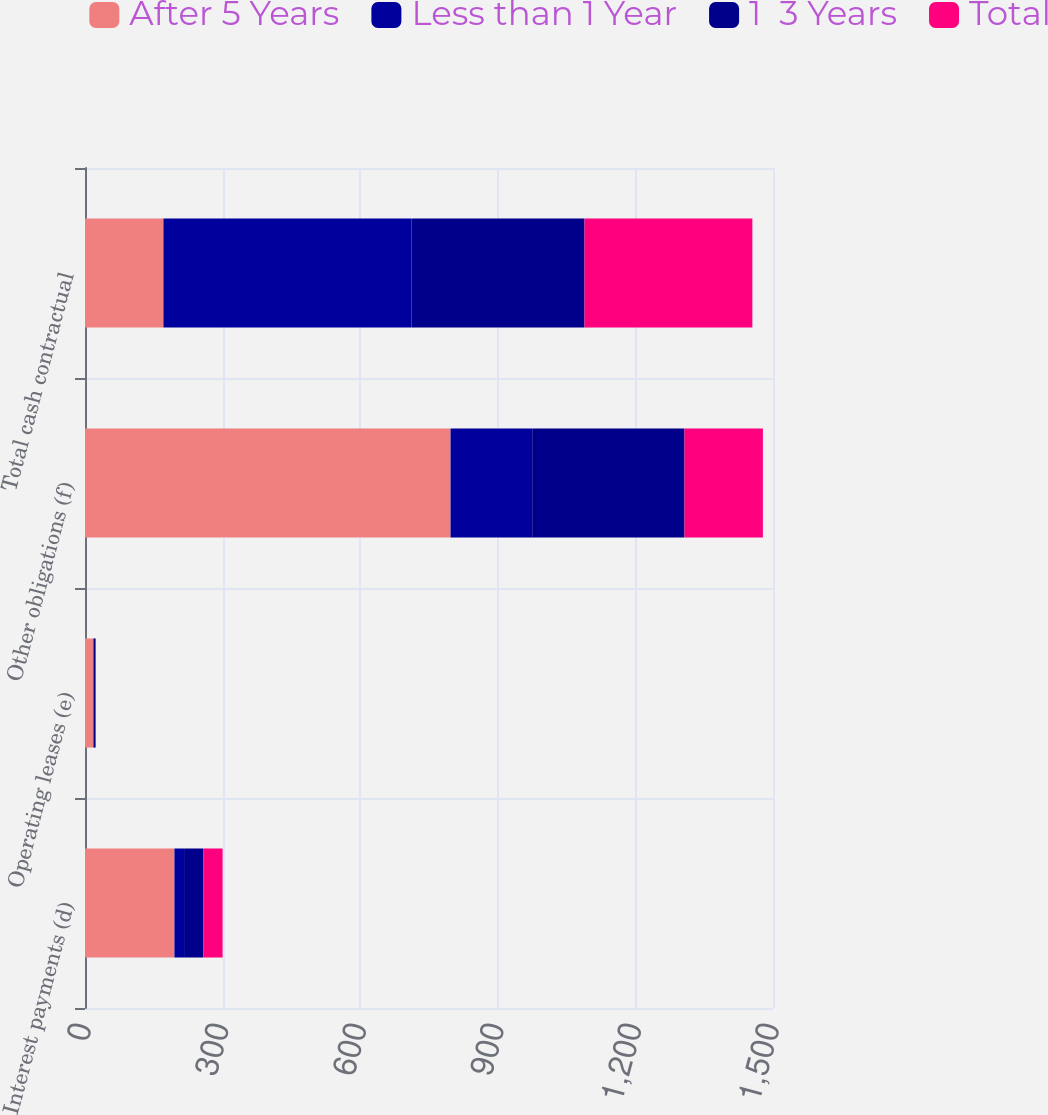Convert chart to OTSL. <chart><loc_0><loc_0><loc_500><loc_500><stacked_bar_chart><ecel><fcel>Interest payments (d)<fcel>Operating leases (e)<fcel>Other obligations (f)<fcel>Total cash contractual<nl><fcel>After 5 Years<fcel>195<fcel>18<fcel>797<fcel>171<nl><fcel>Less than 1 Year<fcel>21<fcel>1<fcel>178<fcel>541<nl><fcel>1  3 Years<fcel>42<fcel>3<fcel>332<fcel>377<nl><fcel>Total<fcel>42<fcel>2<fcel>171<fcel>366<nl></chart> 